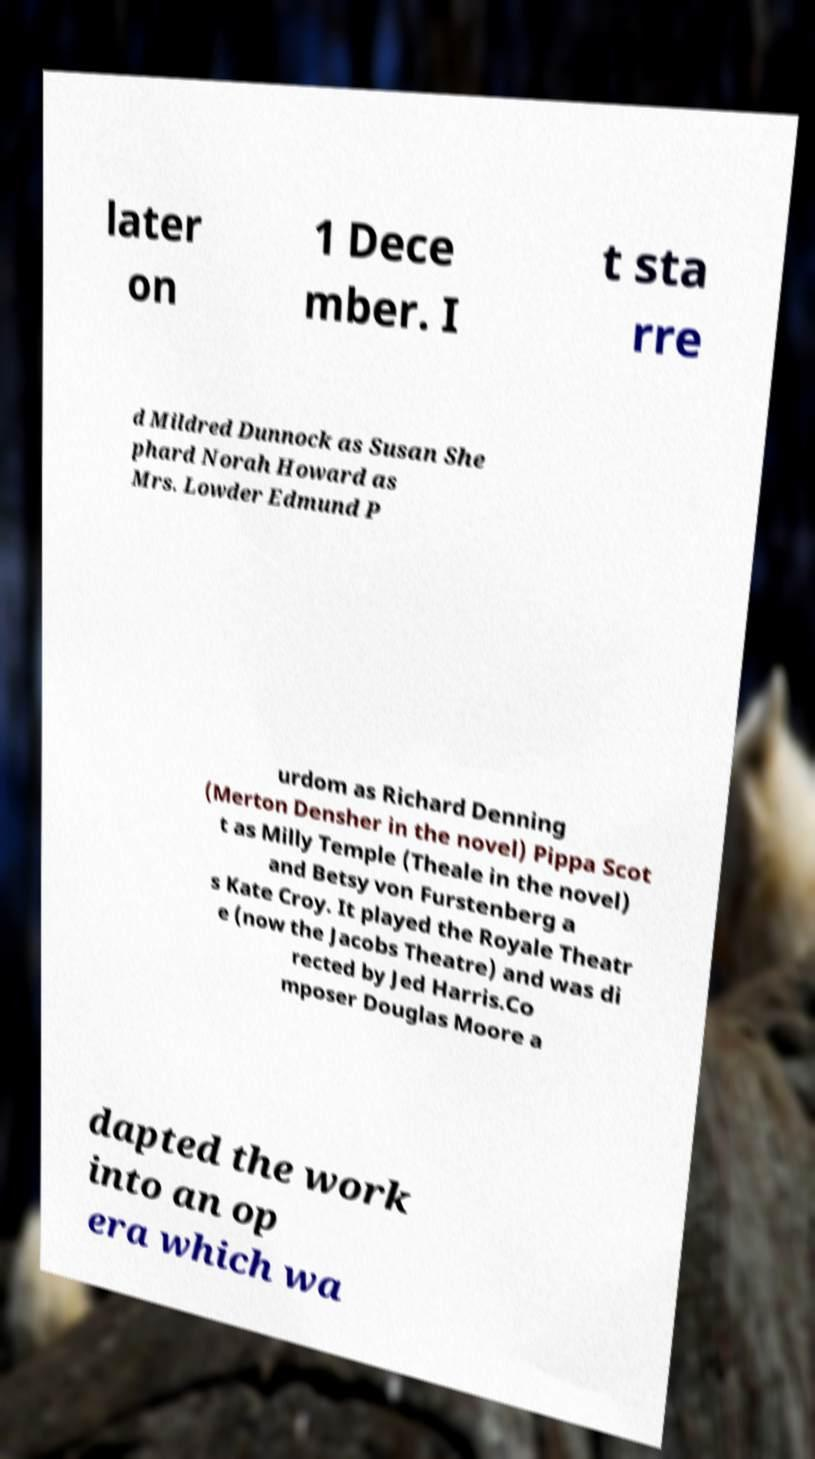Could you extract and type out the text from this image? later on 1 Dece mber. I t sta rre d Mildred Dunnock as Susan She phard Norah Howard as Mrs. Lowder Edmund P urdom as Richard Denning (Merton Densher in the novel) Pippa Scot t as Milly Temple (Theale in the novel) and Betsy von Furstenberg a s Kate Croy. It played the Royale Theatr e (now the Jacobs Theatre) and was di rected by Jed Harris.Co mposer Douglas Moore a dapted the work into an op era which wa 